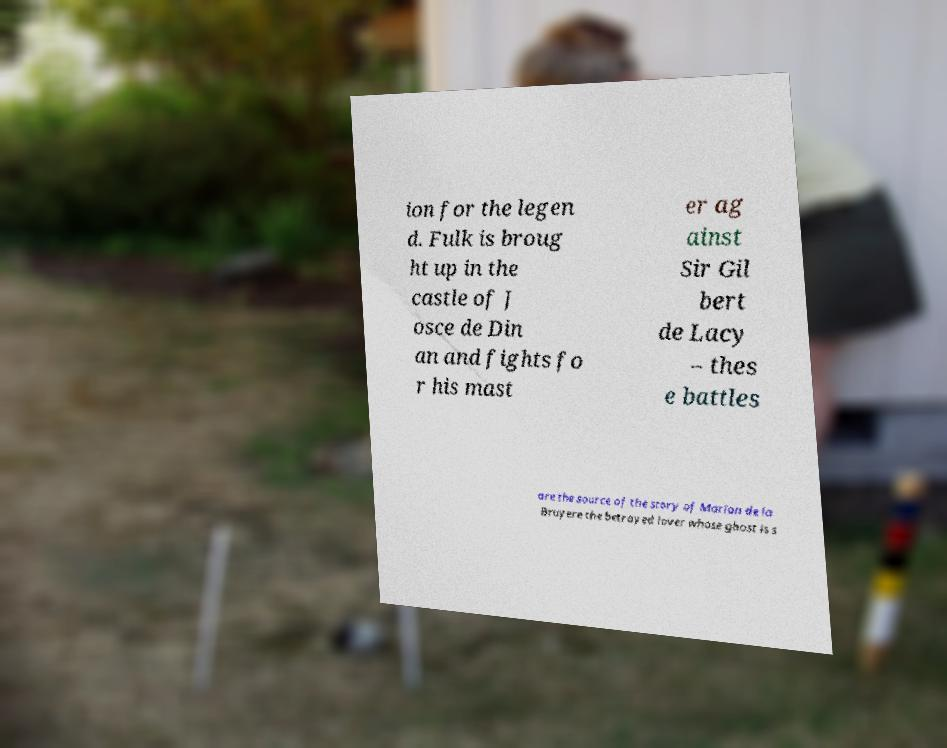What messages or text are displayed in this image? I need them in a readable, typed format. ion for the legen d. Fulk is broug ht up in the castle of J osce de Din an and fights fo r his mast er ag ainst Sir Gil bert de Lacy – thes e battles are the source of the story of Marion de la Bruyere the betrayed lover whose ghost is s 